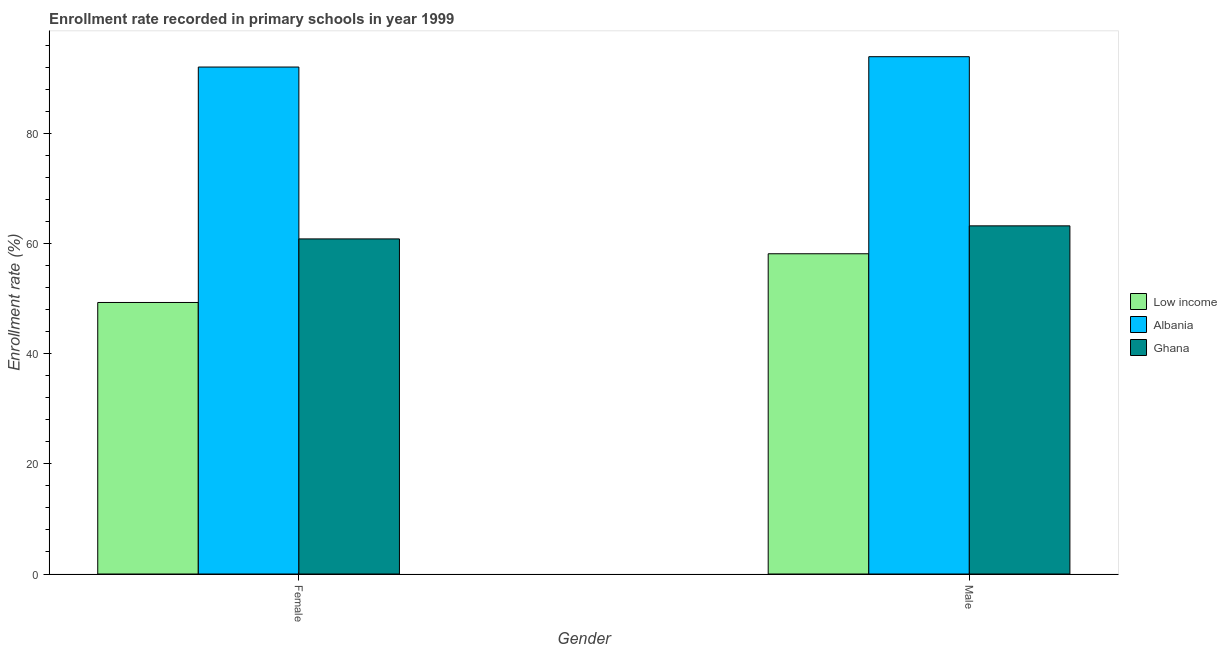Are the number of bars per tick equal to the number of legend labels?
Your response must be concise. Yes. What is the enrollment rate of male students in Ghana?
Ensure brevity in your answer.  63.26. Across all countries, what is the maximum enrollment rate of male students?
Ensure brevity in your answer.  94. Across all countries, what is the minimum enrollment rate of female students?
Give a very brief answer. 49.34. In which country was the enrollment rate of male students maximum?
Give a very brief answer. Albania. What is the total enrollment rate of male students in the graph?
Make the answer very short. 215.46. What is the difference between the enrollment rate of male students in Low income and that in Albania?
Offer a terse response. -35.81. What is the difference between the enrollment rate of female students in Albania and the enrollment rate of male students in Low income?
Make the answer very short. 33.93. What is the average enrollment rate of female students per country?
Your answer should be very brief. 67.45. What is the difference between the enrollment rate of female students and enrollment rate of male students in Low income?
Offer a terse response. -8.85. In how many countries, is the enrollment rate of male students greater than 72 %?
Provide a short and direct response. 1. What is the ratio of the enrollment rate of male students in Ghana to that in Low income?
Give a very brief answer. 1.09. Is the enrollment rate of female students in Ghana less than that in Low income?
Ensure brevity in your answer.  No. What does the 2nd bar from the left in Female represents?
Provide a short and direct response. Albania. What does the 2nd bar from the right in Male represents?
Your answer should be compact. Albania. Are all the bars in the graph horizontal?
Offer a very short reply. No. How many countries are there in the graph?
Your answer should be compact. 3. What is the difference between two consecutive major ticks on the Y-axis?
Ensure brevity in your answer.  20. Are the values on the major ticks of Y-axis written in scientific E-notation?
Keep it short and to the point. No. Does the graph contain grids?
Ensure brevity in your answer.  No. Where does the legend appear in the graph?
Offer a very short reply. Center right. What is the title of the graph?
Offer a very short reply. Enrollment rate recorded in primary schools in year 1999. Does "Ecuador" appear as one of the legend labels in the graph?
Give a very brief answer. No. What is the label or title of the X-axis?
Give a very brief answer. Gender. What is the label or title of the Y-axis?
Offer a very short reply. Enrollment rate (%). What is the Enrollment rate (%) in Low income in Female?
Ensure brevity in your answer.  49.34. What is the Enrollment rate (%) in Albania in Female?
Offer a terse response. 92.12. What is the Enrollment rate (%) of Ghana in Female?
Keep it short and to the point. 60.89. What is the Enrollment rate (%) of Low income in Male?
Offer a very short reply. 58.19. What is the Enrollment rate (%) in Albania in Male?
Give a very brief answer. 94. What is the Enrollment rate (%) in Ghana in Male?
Make the answer very short. 63.26. Across all Gender, what is the maximum Enrollment rate (%) in Low income?
Your answer should be very brief. 58.19. Across all Gender, what is the maximum Enrollment rate (%) in Albania?
Make the answer very short. 94. Across all Gender, what is the maximum Enrollment rate (%) of Ghana?
Give a very brief answer. 63.26. Across all Gender, what is the minimum Enrollment rate (%) of Low income?
Provide a short and direct response. 49.34. Across all Gender, what is the minimum Enrollment rate (%) in Albania?
Your answer should be compact. 92.12. Across all Gender, what is the minimum Enrollment rate (%) in Ghana?
Your response must be concise. 60.89. What is the total Enrollment rate (%) of Low income in the graph?
Ensure brevity in your answer.  107.53. What is the total Enrollment rate (%) of Albania in the graph?
Provide a succinct answer. 186.13. What is the total Enrollment rate (%) of Ghana in the graph?
Provide a short and direct response. 124.15. What is the difference between the Enrollment rate (%) of Low income in Female and that in Male?
Offer a terse response. -8.85. What is the difference between the Enrollment rate (%) in Albania in Female and that in Male?
Offer a terse response. -1.88. What is the difference between the Enrollment rate (%) in Ghana in Female and that in Male?
Provide a short and direct response. -2.37. What is the difference between the Enrollment rate (%) of Low income in Female and the Enrollment rate (%) of Albania in Male?
Offer a terse response. -44.66. What is the difference between the Enrollment rate (%) of Low income in Female and the Enrollment rate (%) of Ghana in Male?
Keep it short and to the point. -13.92. What is the difference between the Enrollment rate (%) in Albania in Female and the Enrollment rate (%) in Ghana in Male?
Provide a short and direct response. 28.86. What is the average Enrollment rate (%) of Low income per Gender?
Offer a very short reply. 53.77. What is the average Enrollment rate (%) of Albania per Gender?
Ensure brevity in your answer.  93.06. What is the average Enrollment rate (%) of Ghana per Gender?
Keep it short and to the point. 62.08. What is the difference between the Enrollment rate (%) in Low income and Enrollment rate (%) in Albania in Female?
Your response must be concise. -42.78. What is the difference between the Enrollment rate (%) of Low income and Enrollment rate (%) of Ghana in Female?
Give a very brief answer. -11.55. What is the difference between the Enrollment rate (%) in Albania and Enrollment rate (%) in Ghana in Female?
Make the answer very short. 31.23. What is the difference between the Enrollment rate (%) of Low income and Enrollment rate (%) of Albania in Male?
Your answer should be compact. -35.81. What is the difference between the Enrollment rate (%) in Low income and Enrollment rate (%) in Ghana in Male?
Offer a very short reply. -5.07. What is the difference between the Enrollment rate (%) in Albania and Enrollment rate (%) in Ghana in Male?
Provide a short and direct response. 30.74. What is the ratio of the Enrollment rate (%) of Low income in Female to that in Male?
Make the answer very short. 0.85. What is the ratio of the Enrollment rate (%) of Albania in Female to that in Male?
Offer a very short reply. 0.98. What is the ratio of the Enrollment rate (%) of Ghana in Female to that in Male?
Your answer should be compact. 0.96. What is the difference between the highest and the second highest Enrollment rate (%) of Low income?
Offer a very short reply. 8.85. What is the difference between the highest and the second highest Enrollment rate (%) in Albania?
Give a very brief answer. 1.88. What is the difference between the highest and the second highest Enrollment rate (%) of Ghana?
Provide a succinct answer. 2.37. What is the difference between the highest and the lowest Enrollment rate (%) of Low income?
Make the answer very short. 8.85. What is the difference between the highest and the lowest Enrollment rate (%) of Albania?
Provide a short and direct response. 1.88. What is the difference between the highest and the lowest Enrollment rate (%) in Ghana?
Ensure brevity in your answer.  2.37. 